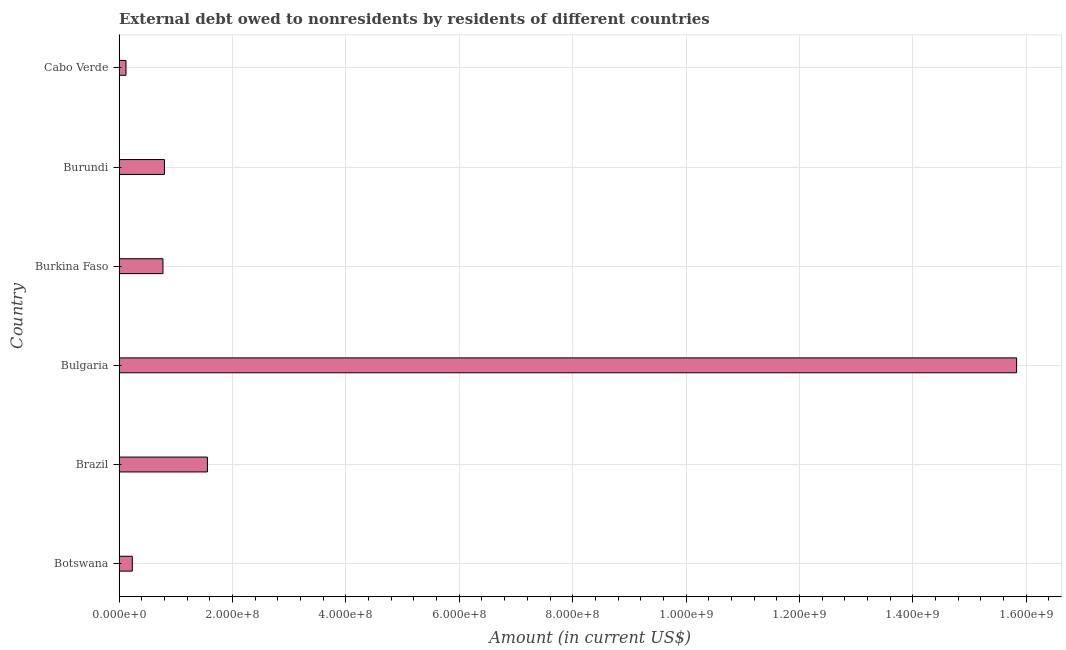Does the graph contain any zero values?
Offer a terse response. No. What is the title of the graph?
Your response must be concise. External debt owed to nonresidents by residents of different countries. What is the debt in Burundi?
Your response must be concise. 8.01e+07. Across all countries, what is the maximum debt?
Your answer should be very brief. 1.58e+09. Across all countries, what is the minimum debt?
Ensure brevity in your answer.  1.22e+07. In which country was the debt minimum?
Provide a succinct answer. Cabo Verde. What is the sum of the debt?
Make the answer very short. 1.93e+09. What is the difference between the debt in Botswana and Bulgaria?
Provide a short and direct response. -1.56e+09. What is the average debt per country?
Give a very brief answer. 3.22e+08. What is the median debt?
Offer a very short reply. 7.87e+07. In how many countries, is the debt greater than 1360000000 US$?
Offer a very short reply. 1. What is the ratio of the debt in Bulgaria to that in Cabo Verde?
Your answer should be compact. 129.51. Is the debt in Botswana less than that in Burkina Faso?
Your answer should be compact. Yes. What is the difference between the highest and the second highest debt?
Offer a very short reply. 1.43e+09. What is the difference between the highest and the lowest debt?
Your answer should be very brief. 1.57e+09. In how many countries, is the debt greater than the average debt taken over all countries?
Offer a very short reply. 1. Are all the bars in the graph horizontal?
Provide a short and direct response. Yes. What is the difference between two consecutive major ticks on the X-axis?
Make the answer very short. 2.00e+08. Are the values on the major ticks of X-axis written in scientific E-notation?
Give a very brief answer. Yes. What is the Amount (in current US$) in Botswana?
Give a very brief answer. 2.34e+07. What is the Amount (in current US$) of Brazil?
Provide a short and direct response. 1.56e+08. What is the Amount (in current US$) in Bulgaria?
Provide a succinct answer. 1.58e+09. What is the Amount (in current US$) in Burkina Faso?
Your answer should be very brief. 7.74e+07. What is the Amount (in current US$) in Burundi?
Offer a terse response. 8.01e+07. What is the Amount (in current US$) of Cabo Verde?
Your answer should be very brief. 1.22e+07. What is the difference between the Amount (in current US$) in Botswana and Brazil?
Provide a succinct answer. -1.32e+08. What is the difference between the Amount (in current US$) in Botswana and Bulgaria?
Your answer should be compact. -1.56e+09. What is the difference between the Amount (in current US$) in Botswana and Burkina Faso?
Provide a short and direct response. -5.41e+07. What is the difference between the Amount (in current US$) in Botswana and Burundi?
Provide a short and direct response. -5.67e+07. What is the difference between the Amount (in current US$) in Botswana and Cabo Verde?
Keep it short and to the point. 1.12e+07. What is the difference between the Amount (in current US$) in Brazil and Bulgaria?
Offer a terse response. -1.43e+09. What is the difference between the Amount (in current US$) in Brazil and Burkina Faso?
Make the answer very short. 7.84e+07. What is the difference between the Amount (in current US$) in Brazil and Burundi?
Your answer should be compact. 7.58e+07. What is the difference between the Amount (in current US$) in Brazil and Cabo Verde?
Give a very brief answer. 1.44e+08. What is the difference between the Amount (in current US$) in Bulgaria and Burkina Faso?
Give a very brief answer. 1.51e+09. What is the difference between the Amount (in current US$) in Bulgaria and Burundi?
Your answer should be very brief. 1.50e+09. What is the difference between the Amount (in current US$) in Bulgaria and Cabo Verde?
Your answer should be very brief. 1.57e+09. What is the difference between the Amount (in current US$) in Burkina Faso and Burundi?
Your answer should be compact. -2.62e+06. What is the difference between the Amount (in current US$) in Burkina Faso and Cabo Verde?
Ensure brevity in your answer.  6.52e+07. What is the difference between the Amount (in current US$) in Burundi and Cabo Verde?
Your answer should be very brief. 6.78e+07. What is the ratio of the Amount (in current US$) in Botswana to that in Bulgaria?
Keep it short and to the point. 0.01. What is the ratio of the Amount (in current US$) in Botswana to that in Burkina Faso?
Offer a terse response. 0.3. What is the ratio of the Amount (in current US$) in Botswana to that in Burundi?
Provide a succinct answer. 0.29. What is the ratio of the Amount (in current US$) in Botswana to that in Cabo Verde?
Offer a terse response. 1.91. What is the ratio of the Amount (in current US$) in Brazil to that in Bulgaria?
Make the answer very short. 0.1. What is the ratio of the Amount (in current US$) in Brazil to that in Burkina Faso?
Offer a very short reply. 2.01. What is the ratio of the Amount (in current US$) in Brazil to that in Burundi?
Your answer should be compact. 1.95. What is the ratio of the Amount (in current US$) in Brazil to that in Cabo Verde?
Provide a short and direct response. 12.75. What is the ratio of the Amount (in current US$) in Bulgaria to that in Burkina Faso?
Your response must be concise. 20.44. What is the ratio of the Amount (in current US$) in Bulgaria to that in Burundi?
Keep it short and to the point. 19.77. What is the ratio of the Amount (in current US$) in Bulgaria to that in Cabo Verde?
Keep it short and to the point. 129.51. What is the ratio of the Amount (in current US$) in Burkina Faso to that in Cabo Verde?
Ensure brevity in your answer.  6.34. What is the ratio of the Amount (in current US$) in Burundi to that in Cabo Verde?
Ensure brevity in your answer.  6.55. 